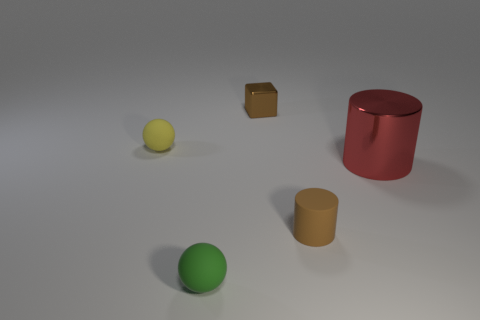Are there any small brown cylinders made of the same material as the brown cube?
Your response must be concise. No. How many objects are either small brown objects on the right side of the brown cube or small yellow matte objects?
Offer a terse response. 2. Do the ball that is in front of the big metal cylinder and the tiny block have the same material?
Give a very brief answer. No. Do the brown metallic object and the brown matte thing have the same shape?
Your answer should be very brief. No. There is a sphere behind the small brown matte cylinder; how many yellow things are to the left of it?
Give a very brief answer. 0. There is a tiny object that is the same shape as the large shiny thing; what is it made of?
Provide a short and direct response. Rubber. Do the ball in front of the tiny brown rubber thing and the small block have the same color?
Ensure brevity in your answer.  No. Are the small cylinder and the thing that is behind the yellow matte thing made of the same material?
Keep it short and to the point. No. What is the shape of the small matte object that is to the right of the tiny green rubber object?
Offer a terse response. Cylinder. What number of other things are the same material as the brown cylinder?
Offer a very short reply. 2. 